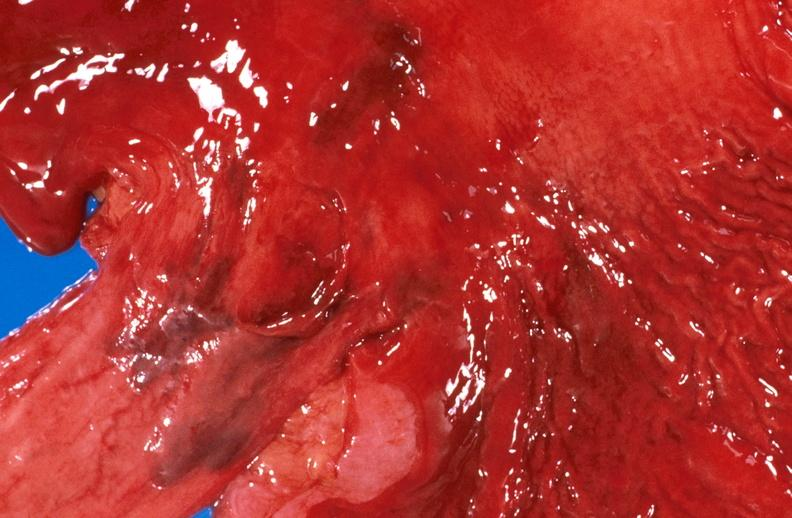why does this image show esophageal varices?
Answer the question using a single word or phrase. Due to alcoholic cirrhosis 